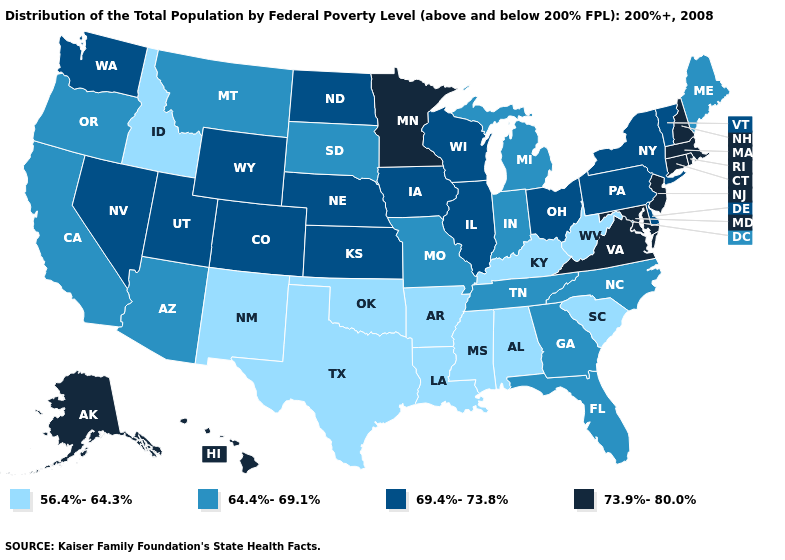Among the states that border Pennsylvania , which have the highest value?
Answer briefly. Maryland, New Jersey. Does Iowa have the lowest value in the MidWest?
Keep it brief. No. Name the states that have a value in the range 64.4%-69.1%?
Concise answer only. Arizona, California, Florida, Georgia, Indiana, Maine, Michigan, Missouri, Montana, North Carolina, Oregon, South Dakota, Tennessee. Name the states that have a value in the range 64.4%-69.1%?
Answer briefly. Arizona, California, Florida, Georgia, Indiana, Maine, Michigan, Missouri, Montana, North Carolina, Oregon, South Dakota, Tennessee. Among the states that border Utah , which have the highest value?
Answer briefly. Colorado, Nevada, Wyoming. Among the states that border Montana , which have the lowest value?
Answer briefly. Idaho. What is the highest value in states that border Missouri?
Write a very short answer. 69.4%-73.8%. Name the states that have a value in the range 73.9%-80.0%?
Short answer required. Alaska, Connecticut, Hawaii, Maryland, Massachusetts, Minnesota, New Hampshire, New Jersey, Rhode Island, Virginia. What is the lowest value in states that border Nebraska?
Short answer required. 64.4%-69.1%. What is the lowest value in states that border Idaho?
Short answer required. 64.4%-69.1%. Does Montana have a lower value than Missouri?
Write a very short answer. No. What is the lowest value in the Northeast?
Short answer required. 64.4%-69.1%. Name the states that have a value in the range 69.4%-73.8%?
Concise answer only. Colorado, Delaware, Illinois, Iowa, Kansas, Nebraska, Nevada, New York, North Dakota, Ohio, Pennsylvania, Utah, Vermont, Washington, Wisconsin, Wyoming. Name the states that have a value in the range 64.4%-69.1%?
Be succinct. Arizona, California, Florida, Georgia, Indiana, Maine, Michigan, Missouri, Montana, North Carolina, Oregon, South Dakota, Tennessee. 